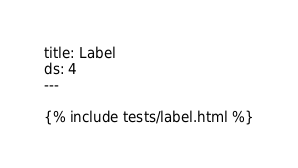<code> <loc_0><loc_0><loc_500><loc_500><_HTML_>title: Label
ds: 4
---

{% include tests/label.html %}
</code> 